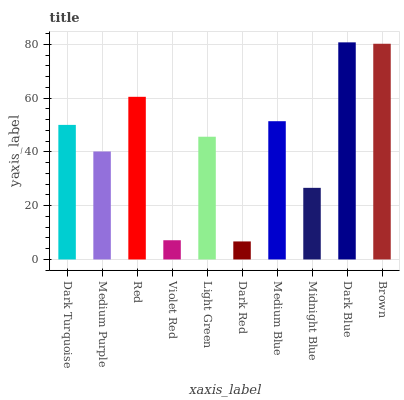Is Dark Red the minimum?
Answer yes or no. Yes. Is Dark Blue the maximum?
Answer yes or no. Yes. Is Medium Purple the minimum?
Answer yes or no. No. Is Medium Purple the maximum?
Answer yes or no. No. Is Dark Turquoise greater than Medium Purple?
Answer yes or no. Yes. Is Medium Purple less than Dark Turquoise?
Answer yes or no. Yes. Is Medium Purple greater than Dark Turquoise?
Answer yes or no. No. Is Dark Turquoise less than Medium Purple?
Answer yes or no. No. Is Dark Turquoise the high median?
Answer yes or no. Yes. Is Light Green the low median?
Answer yes or no. Yes. Is Midnight Blue the high median?
Answer yes or no. No. Is Midnight Blue the low median?
Answer yes or no. No. 